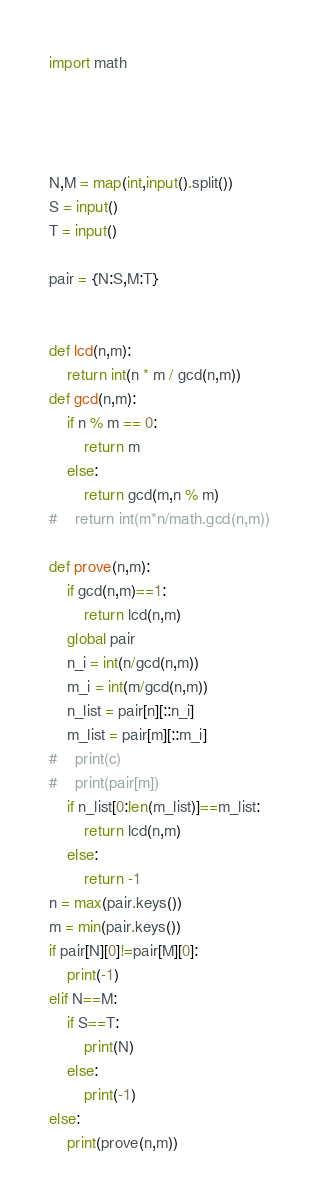Convert code to text. <code><loc_0><loc_0><loc_500><loc_500><_Python_>import math

 

 
N,M = map(int,input().split())
S = input()
T = input()

pair = {N:S,M:T}


def lcd(n,m):
    return int(n * m / gcd(n,m))
def gcd(n,m):
    if n % m == 0:
        return m
    else:
        return gcd(m,n % m)
#    return int(m*n/math.gcd(n,m))
    
def prove(n,m):
    if gcd(n,m)==1:
        return lcd(n,m)
    global pair
    n_i = int(n/gcd(n,m))
    m_i = int(m/gcd(n,m))
    n_list = pair[n][::n_i]
    m_list = pair[m][::m_i]
#    print(c)
#    print(pair[m])
    if n_list[0:len(m_list)]==m_list:
        return lcd(n,m)
    else:
        return -1
n = max(pair.keys())
m = min(pair.keys())
if pair[N][0]!=pair[M][0]:
    print(-1)
elif N==M:
    if S==T:
        print(N)
    else:
        print(-1)
else:
    print(prove(n,m))

</code> 